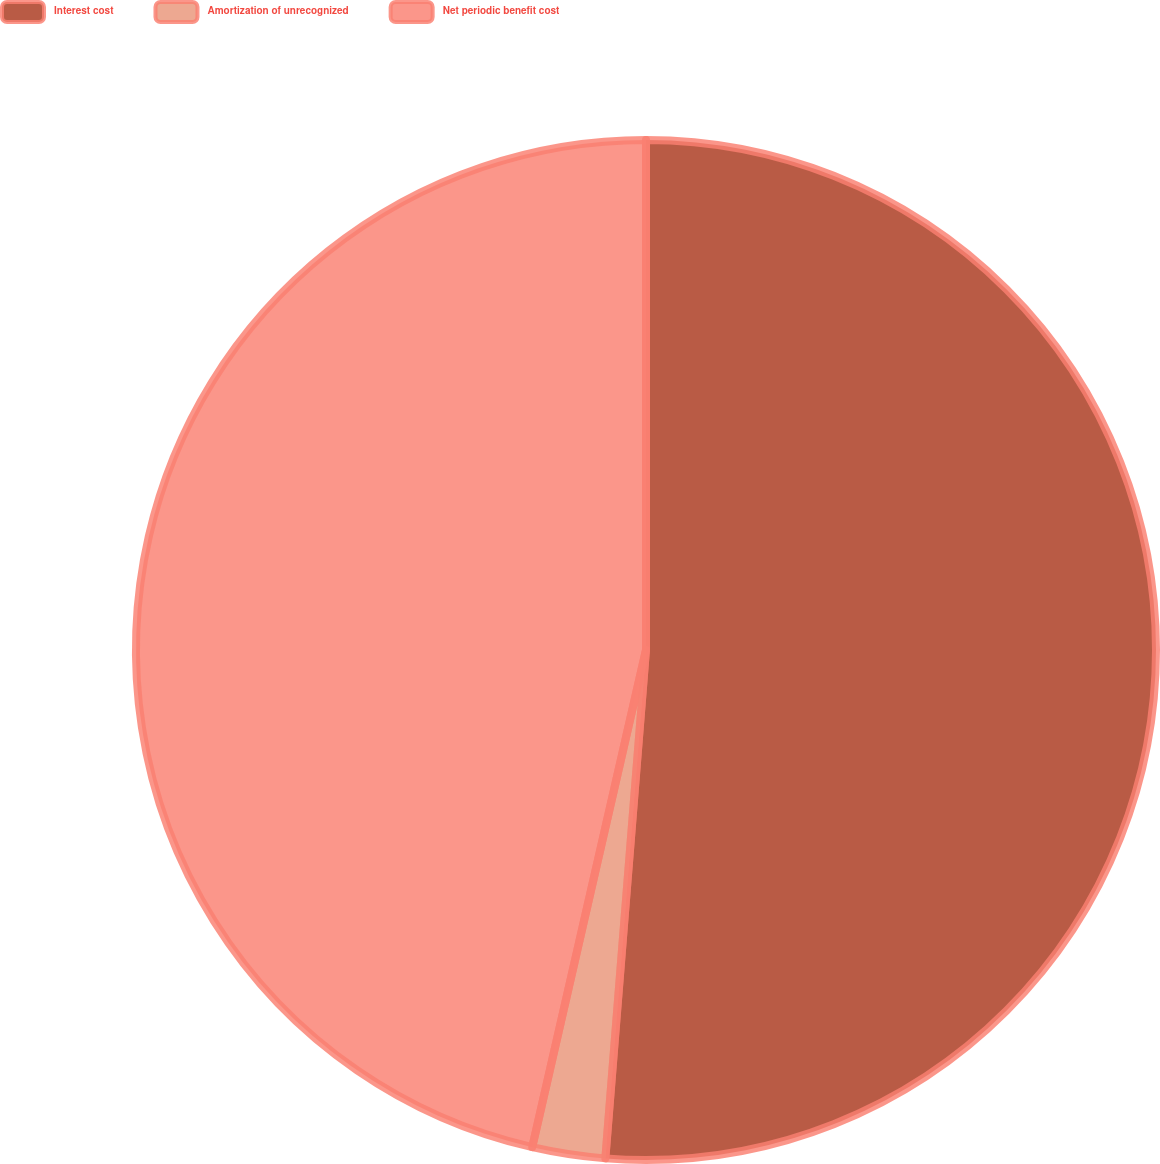<chart> <loc_0><loc_0><loc_500><loc_500><pie_chart><fcel>Interest cost<fcel>Amortization of unrecognized<fcel>Net periodic benefit cost<nl><fcel>51.27%<fcel>2.31%<fcel>46.42%<nl></chart> 